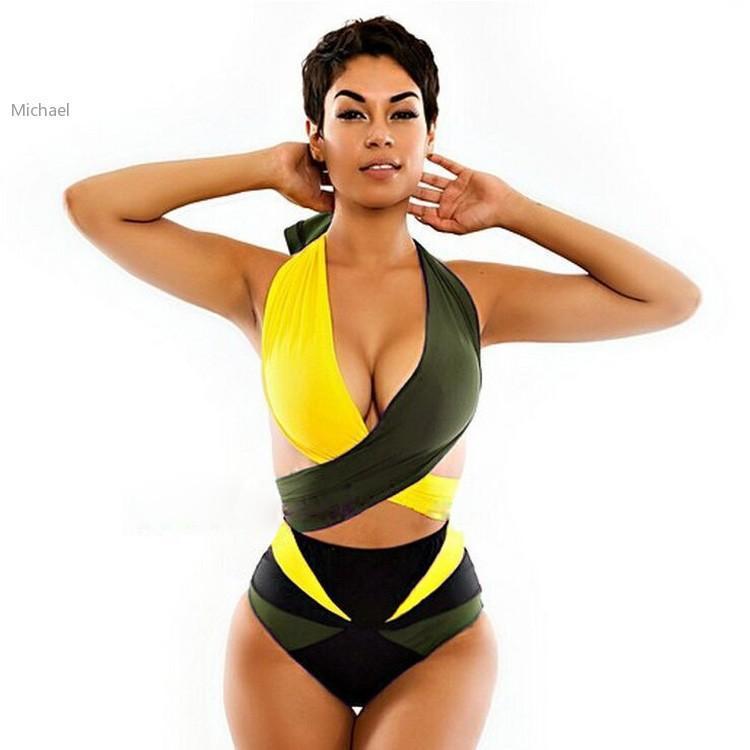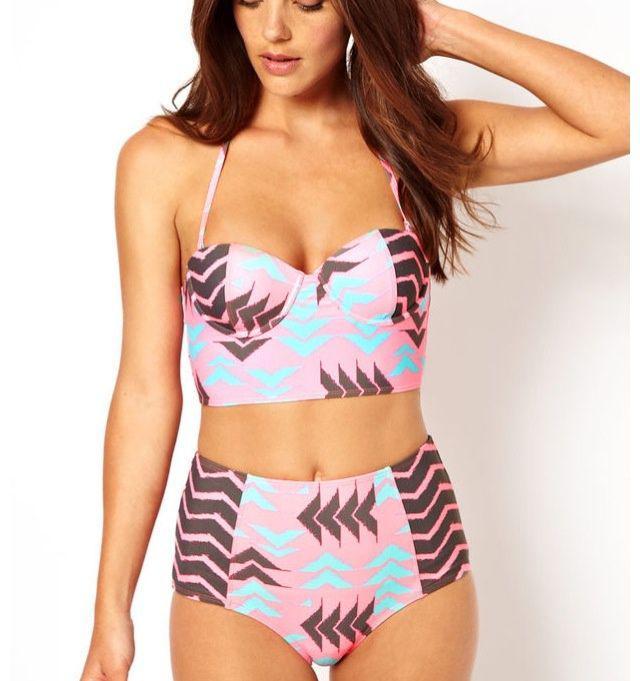The first image is the image on the left, the second image is the image on the right. Examine the images to the left and right. Is the description "One of the models is wearing sunglasses." accurate? Answer yes or no. No. 